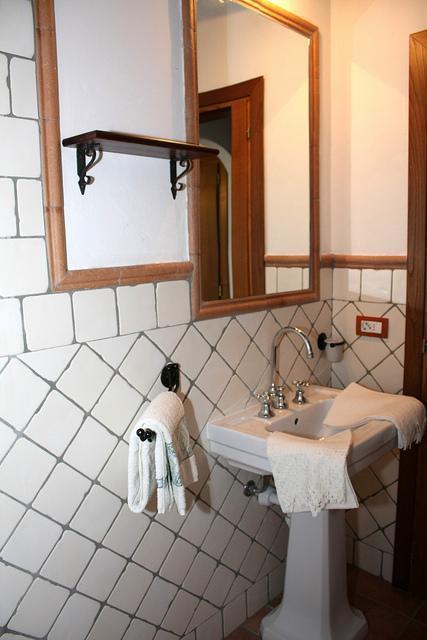How many towels are on the sink?
Give a very brief answer. 2. 